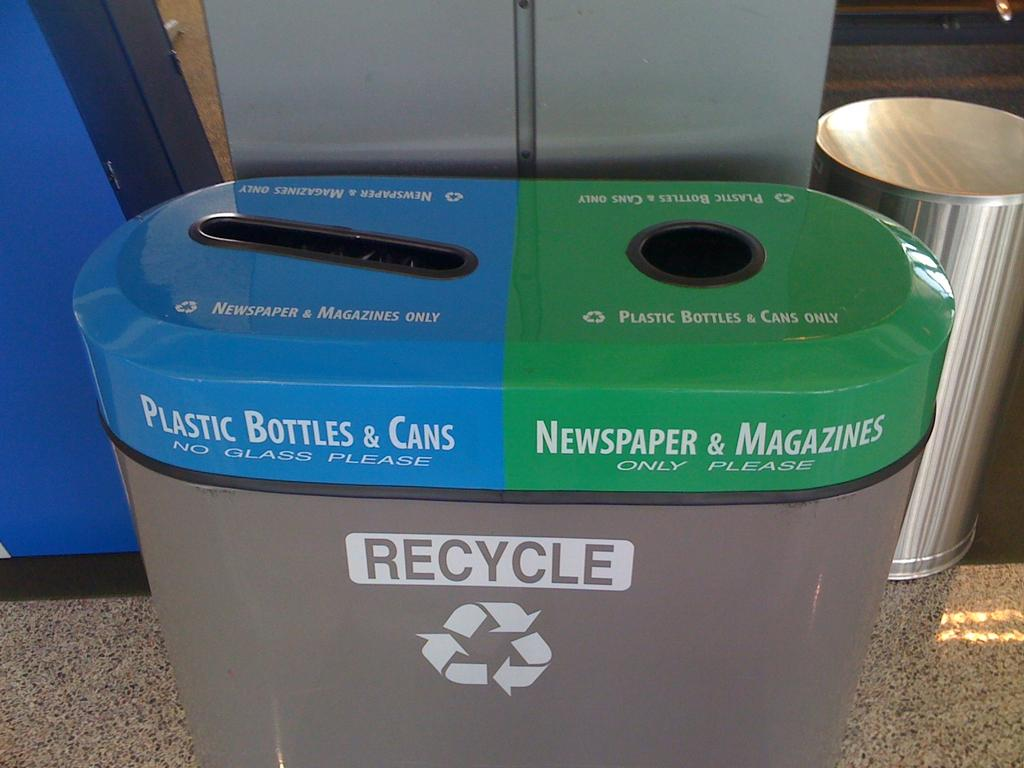Provide a one-sentence caption for the provided image. A recycling bin is shown, with the blue side for Plastic Bottles & Cans and the green side for Newspapers & Magazines. 